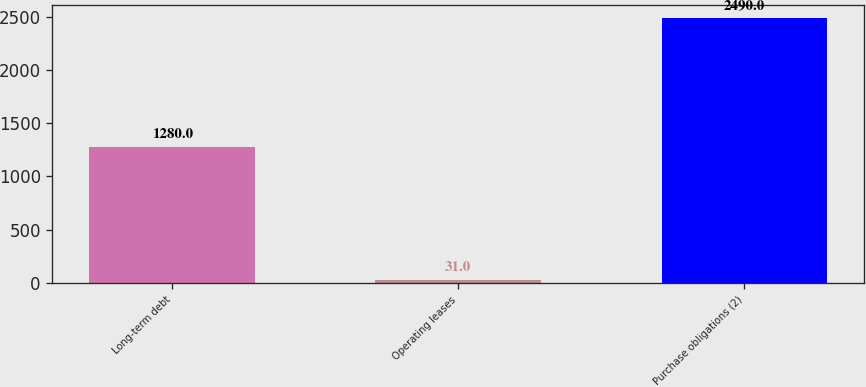Convert chart to OTSL. <chart><loc_0><loc_0><loc_500><loc_500><bar_chart><fcel>Long-term debt<fcel>Operating leases<fcel>Purchase obligations (2)<nl><fcel>1280<fcel>31<fcel>2490<nl></chart> 